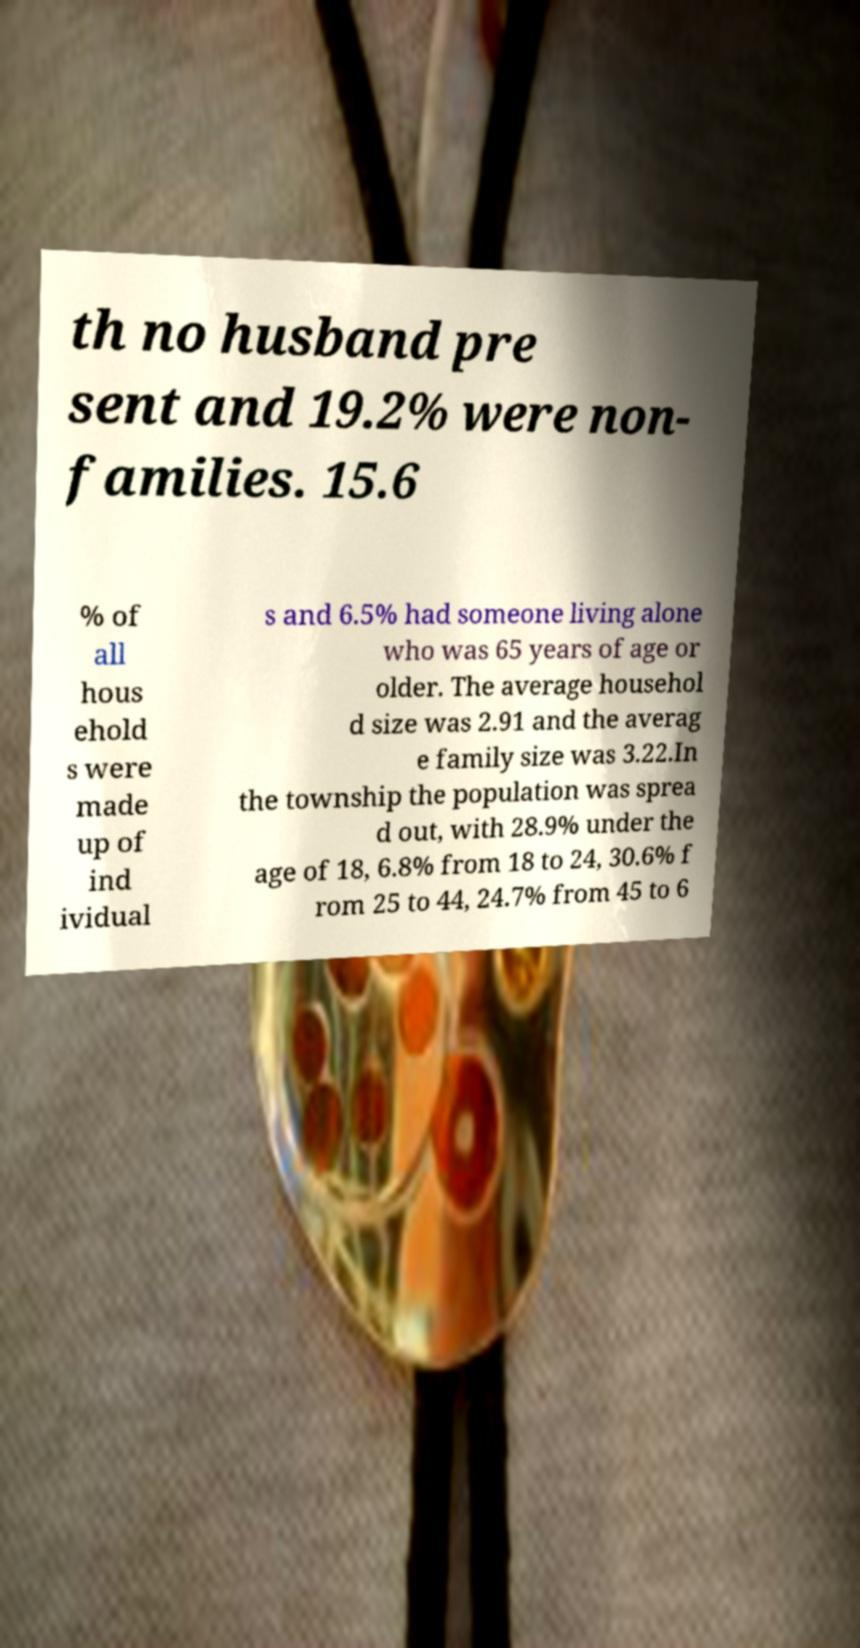Please identify and transcribe the text found in this image. th no husband pre sent and 19.2% were non- families. 15.6 % of all hous ehold s were made up of ind ividual s and 6.5% had someone living alone who was 65 years of age or older. The average househol d size was 2.91 and the averag e family size was 3.22.In the township the population was sprea d out, with 28.9% under the age of 18, 6.8% from 18 to 24, 30.6% f rom 25 to 44, 24.7% from 45 to 6 